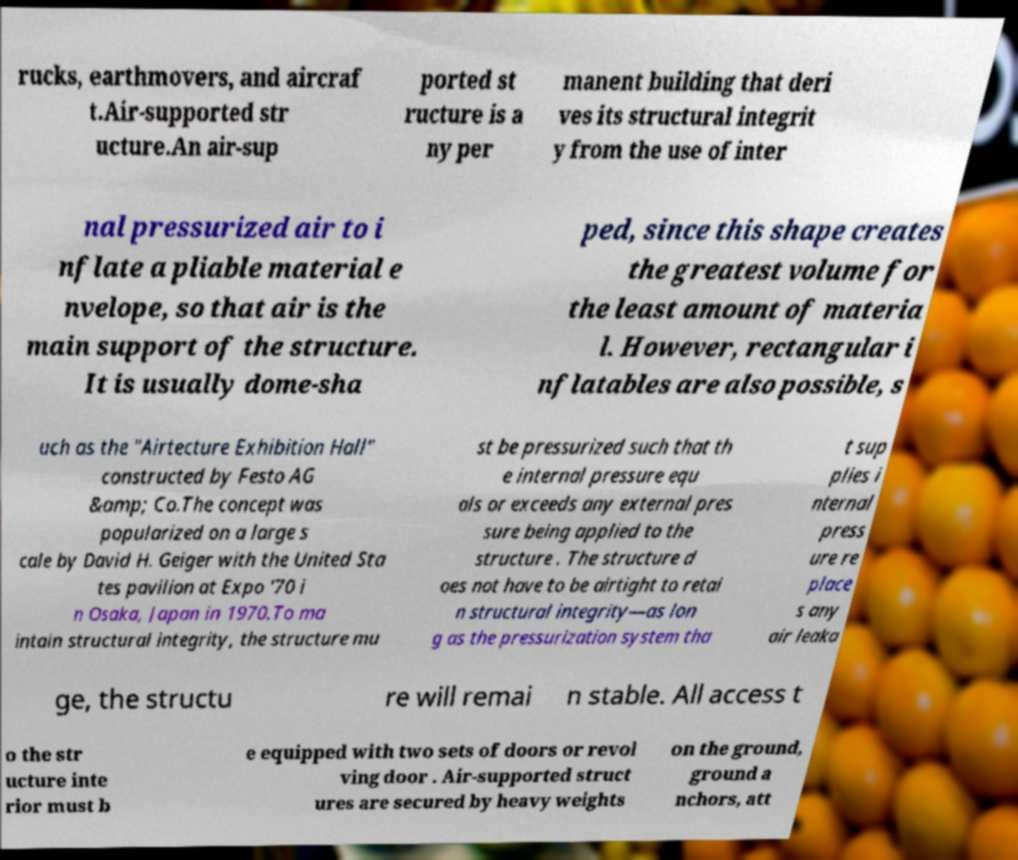There's text embedded in this image that I need extracted. Can you transcribe it verbatim? rucks, earthmovers, and aircraf t.Air-supported str ucture.An air-sup ported st ructure is a ny per manent building that deri ves its structural integrit y from the use of inter nal pressurized air to i nflate a pliable material e nvelope, so that air is the main support of the structure. It is usually dome-sha ped, since this shape creates the greatest volume for the least amount of materia l. However, rectangular i nflatables are also possible, s uch as the "Airtecture Exhibition Hall" constructed by Festo AG &amp; Co.The concept was popularized on a large s cale by David H. Geiger with the United Sta tes pavilion at Expo '70 i n Osaka, Japan in 1970.To ma intain structural integrity, the structure mu st be pressurized such that th e internal pressure equ als or exceeds any external pres sure being applied to the structure . The structure d oes not have to be airtight to retai n structural integrity—as lon g as the pressurization system tha t sup plies i nternal press ure re place s any air leaka ge, the structu re will remai n stable. All access t o the str ucture inte rior must b e equipped with two sets of doors or revol ving door . Air-supported struct ures are secured by heavy weights on the ground, ground a nchors, att 